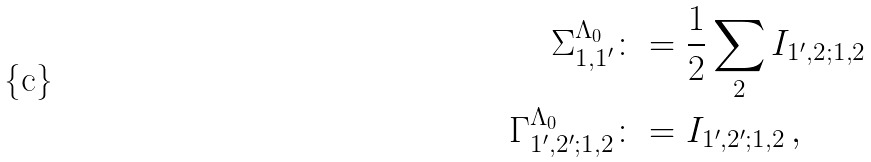Convert formula to latex. <formula><loc_0><loc_0><loc_500><loc_500>\Sigma _ { 1 , 1 ^ { \prime } } ^ { \Lambda _ { 0 } } & \colon = \frac { 1 } { 2 } \sum _ { 2 } I _ { 1 ^ { \prime } , 2 ; 1 , 2 } \\ \Gamma _ { 1 ^ { \prime } , 2 ^ { \prime } ; 1 , 2 } ^ { \Lambda _ { 0 } } & \colon = I _ { 1 ^ { \prime } , 2 ^ { \prime } ; 1 , 2 } \, ,</formula> 